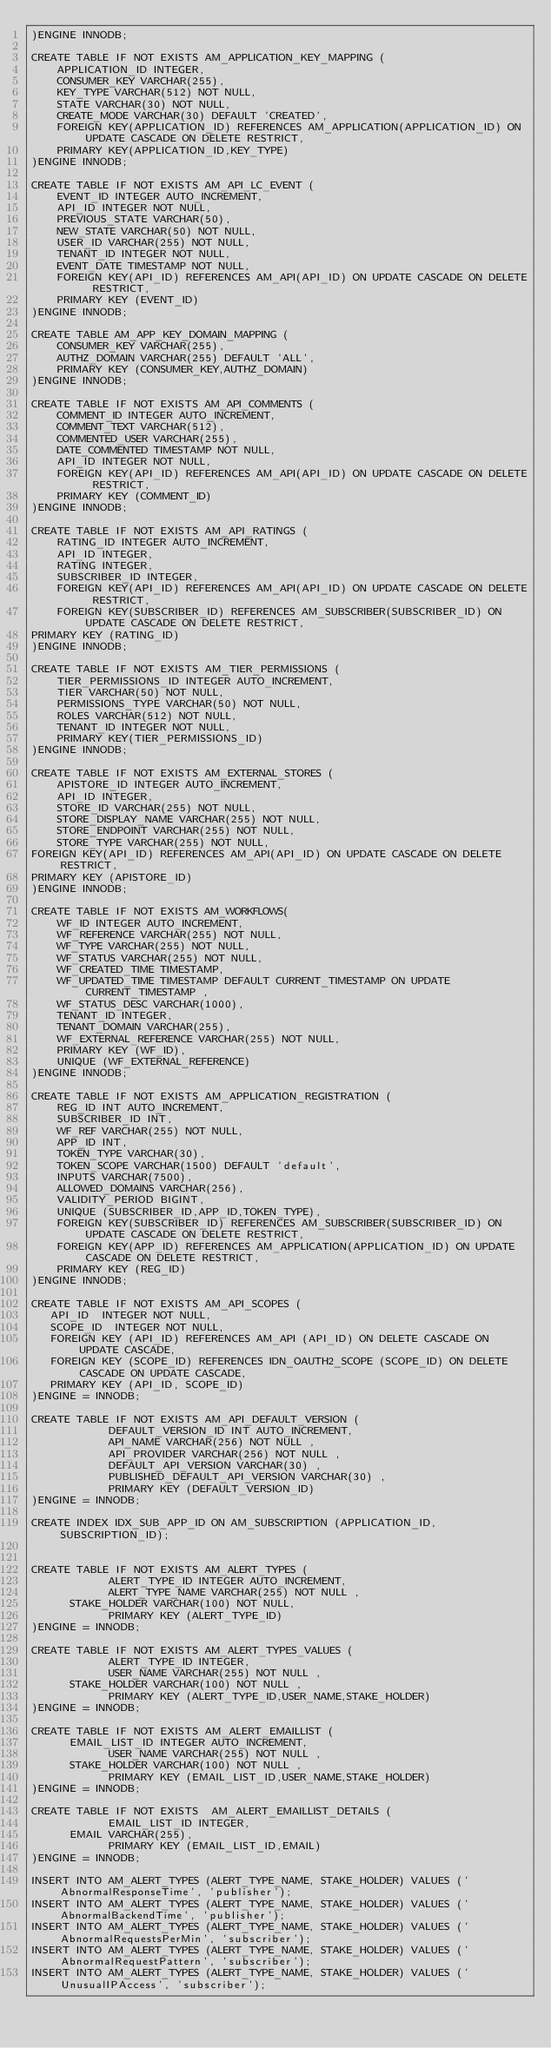Convert code to text. <code><loc_0><loc_0><loc_500><loc_500><_SQL_>)ENGINE INNODB;

CREATE TABLE IF NOT EXISTS AM_APPLICATION_KEY_MAPPING (
    APPLICATION_ID INTEGER,
    CONSUMER_KEY VARCHAR(255),
    KEY_TYPE VARCHAR(512) NOT NULL,
    STATE VARCHAR(30) NOT NULL,
    CREATE_MODE VARCHAR(30) DEFAULT 'CREATED',
    FOREIGN KEY(APPLICATION_ID) REFERENCES AM_APPLICATION(APPLICATION_ID) ON UPDATE CASCADE ON DELETE RESTRICT,
    PRIMARY KEY(APPLICATION_ID,KEY_TYPE)
)ENGINE INNODB;

CREATE TABLE IF NOT EXISTS AM_API_LC_EVENT (
    EVENT_ID INTEGER AUTO_INCREMENT,
    API_ID INTEGER NOT NULL,
    PREVIOUS_STATE VARCHAR(50),
    NEW_STATE VARCHAR(50) NOT NULL,
    USER_ID VARCHAR(255) NOT NULL,
    TENANT_ID INTEGER NOT NULL,
    EVENT_DATE TIMESTAMP NOT NULL,
    FOREIGN KEY(API_ID) REFERENCES AM_API(API_ID) ON UPDATE CASCADE ON DELETE RESTRICT,
    PRIMARY KEY (EVENT_ID)
)ENGINE INNODB;

CREATE TABLE AM_APP_KEY_DOMAIN_MAPPING (
    CONSUMER_KEY VARCHAR(255),
    AUTHZ_DOMAIN VARCHAR(255) DEFAULT 'ALL',
    PRIMARY KEY (CONSUMER_KEY,AUTHZ_DOMAIN)
)ENGINE INNODB;

CREATE TABLE IF NOT EXISTS AM_API_COMMENTS (
    COMMENT_ID INTEGER AUTO_INCREMENT,
    COMMENT_TEXT VARCHAR(512),
    COMMENTED_USER VARCHAR(255),
    DATE_COMMENTED TIMESTAMP NOT NULL,
    API_ID INTEGER NOT NULL,
    FOREIGN KEY(API_ID) REFERENCES AM_API(API_ID) ON UPDATE CASCADE ON DELETE RESTRICT,
    PRIMARY KEY (COMMENT_ID)
)ENGINE INNODB;

CREATE TABLE IF NOT EXISTS AM_API_RATINGS (
    RATING_ID INTEGER AUTO_INCREMENT,
    API_ID INTEGER,
    RATING INTEGER,
    SUBSCRIBER_ID INTEGER,
    FOREIGN KEY(API_ID) REFERENCES AM_API(API_ID) ON UPDATE CASCADE ON DELETE RESTRICT,
    FOREIGN KEY(SUBSCRIBER_ID) REFERENCES AM_SUBSCRIBER(SUBSCRIBER_ID) ON UPDATE CASCADE ON DELETE RESTRICT,
PRIMARY KEY (RATING_ID)
)ENGINE INNODB;

CREATE TABLE IF NOT EXISTS AM_TIER_PERMISSIONS (
    TIER_PERMISSIONS_ID INTEGER AUTO_INCREMENT,
    TIER VARCHAR(50) NOT NULL,
    PERMISSIONS_TYPE VARCHAR(50) NOT NULL,
    ROLES VARCHAR(512) NOT NULL,
    TENANT_ID INTEGER NOT NULL,
    PRIMARY KEY(TIER_PERMISSIONS_ID)
)ENGINE INNODB;

CREATE TABLE IF NOT EXISTS AM_EXTERNAL_STORES (
    APISTORE_ID INTEGER AUTO_INCREMENT,
    API_ID INTEGER,
    STORE_ID VARCHAR(255) NOT NULL,
    STORE_DISPLAY_NAME VARCHAR(255) NOT NULL,
    STORE_ENDPOINT VARCHAR(255) NOT NULL,
    STORE_TYPE VARCHAR(255) NOT NULL,
FOREIGN KEY(API_ID) REFERENCES AM_API(API_ID) ON UPDATE CASCADE ON DELETE RESTRICT,
PRIMARY KEY (APISTORE_ID)
)ENGINE INNODB;

CREATE TABLE IF NOT EXISTS AM_WORKFLOWS(
    WF_ID INTEGER AUTO_INCREMENT,
    WF_REFERENCE VARCHAR(255) NOT NULL,
    WF_TYPE VARCHAR(255) NOT NULL,
    WF_STATUS VARCHAR(255) NOT NULL,
    WF_CREATED_TIME TIMESTAMP,
    WF_UPDATED_TIME TIMESTAMP DEFAULT CURRENT_TIMESTAMP ON UPDATE CURRENT_TIMESTAMP ,
    WF_STATUS_DESC VARCHAR(1000),
    TENANT_ID INTEGER,
    TENANT_DOMAIN VARCHAR(255),
    WF_EXTERNAL_REFERENCE VARCHAR(255) NOT NULL,
    PRIMARY KEY (WF_ID),
    UNIQUE (WF_EXTERNAL_REFERENCE)
)ENGINE INNODB;

CREATE TABLE IF NOT EXISTS AM_APPLICATION_REGISTRATION (
    REG_ID INT AUTO_INCREMENT,
    SUBSCRIBER_ID INT,
    WF_REF VARCHAR(255) NOT NULL,
    APP_ID INT,
    TOKEN_TYPE VARCHAR(30),
    TOKEN_SCOPE VARCHAR(1500) DEFAULT 'default',
    INPUTS VARCHAR(7500),
    ALLOWED_DOMAINS VARCHAR(256),
    VALIDITY_PERIOD BIGINT,
    UNIQUE (SUBSCRIBER_ID,APP_ID,TOKEN_TYPE),
    FOREIGN KEY(SUBSCRIBER_ID) REFERENCES AM_SUBSCRIBER(SUBSCRIBER_ID) ON UPDATE CASCADE ON DELETE RESTRICT,
    FOREIGN KEY(APP_ID) REFERENCES AM_APPLICATION(APPLICATION_ID) ON UPDATE CASCADE ON DELETE RESTRICT,
    PRIMARY KEY (REG_ID)
)ENGINE INNODB;

CREATE TABLE IF NOT EXISTS AM_API_SCOPES (
   API_ID  INTEGER NOT NULL,
   SCOPE_ID  INTEGER NOT NULL,
   FOREIGN KEY (API_ID) REFERENCES AM_API (API_ID) ON DELETE CASCADE ON UPDATE CASCADE,
   FOREIGN KEY (SCOPE_ID) REFERENCES IDN_OAUTH2_SCOPE (SCOPE_ID) ON DELETE CASCADE ON UPDATE CASCADE,
   PRIMARY KEY (API_ID, SCOPE_ID)
)ENGINE = INNODB;

CREATE TABLE IF NOT EXISTS AM_API_DEFAULT_VERSION (
            DEFAULT_VERSION_ID INT AUTO_INCREMENT,
            API_NAME VARCHAR(256) NOT NULL ,
            API_PROVIDER VARCHAR(256) NOT NULL ,
            DEFAULT_API_VERSION VARCHAR(30) ,
            PUBLISHED_DEFAULT_API_VERSION VARCHAR(30) ,
            PRIMARY KEY (DEFAULT_VERSION_ID)
)ENGINE = INNODB;

CREATE INDEX IDX_SUB_APP_ID ON AM_SUBSCRIPTION (APPLICATION_ID, SUBSCRIPTION_ID);


CREATE TABLE IF NOT EXISTS AM_ALERT_TYPES (
            ALERT_TYPE_ID INTEGER AUTO_INCREMENT,
            ALERT_TYPE_NAME VARCHAR(255) NOT NULL ,
	    STAKE_HOLDER VARCHAR(100) NOT NULL,
            PRIMARY KEY (ALERT_TYPE_ID)
)ENGINE = INNODB;

CREATE TABLE IF NOT EXISTS AM_ALERT_TYPES_VALUES (
            ALERT_TYPE_ID INTEGER,
            USER_NAME VARCHAR(255) NOT NULL ,
	    STAKE_HOLDER VARCHAR(100) NOT NULL ,
            PRIMARY KEY (ALERT_TYPE_ID,USER_NAME,STAKE_HOLDER)
)ENGINE = INNODB;

CREATE TABLE IF NOT EXISTS AM_ALERT_EMAILLIST (
	    EMAIL_LIST_ID INTEGER AUTO_INCREMENT,
            USER_NAME VARCHAR(255) NOT NULL ,
	    STAKE_HOLDER VARCHAR(100) NOT NULL ,
            PRIMARY KEY (EMAIL_LIST_ID,USER_NAME,STAKE_HOLDER)
)ENGINE = INNODB;

CREATE TABLE IF NOT EXISTS  AM_ALERT_EMAILLIST_DETAILS (
            EMAIL_LIST_ID INTEGER,
	    EMAIL VARCHAR(255),
            PRIMARY KEY (EMAIL_LIST_ID,EMAIL)
)ENGINE = INNODB;

INSERT INTO AM_ALERT_TYPES (ALERT_TYPE_NAME, STAKE_HOLDER) VALUES ('AbnormalResponseTime', 'publisher');
INSERT INTO AM_ALERT_TYPES (ALERT_TYPE_NAME, STAKE_HOLDER) VALUES ('AbnormalBackendTime', 'publisher');
INSERT INTO AM_ALERT_TYPES (ALERT_TYPE_NAME, STAKE_HOLDER) VALUES ('AbnormalRequestsPerMin', 'subscriber');
INSERT INTO AM_ALERT_TYPES (ALERT_TYPE_NAME, STAKE_HOLDER) VALUES ('AbnormalRequestPattern', 'subscriber');
INSERT INTO AM_ALERT_TYPES (ALERT_TYPE_NAME, STAKE_HOLDER) VALUES ('UnusualIPAccess', 'subscriber');</code> 